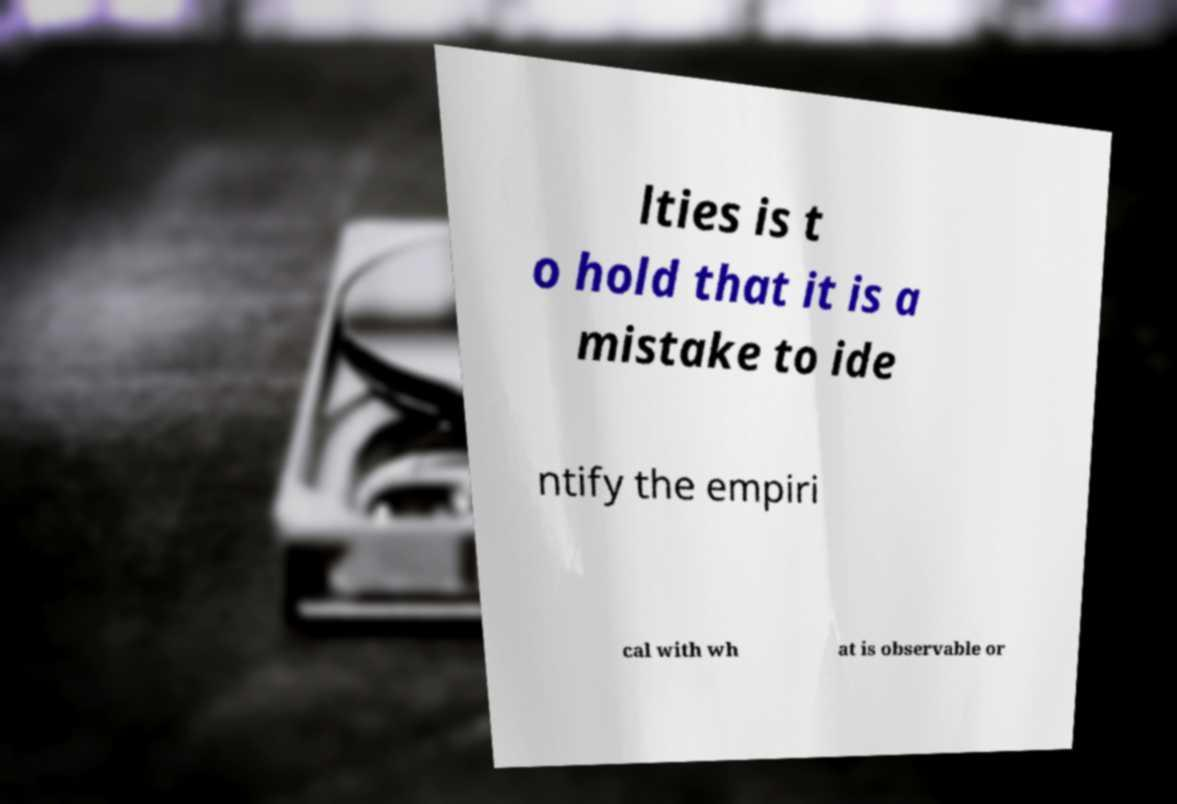Could you extract and type out the text from this image? lties is t o hold that it is a mistake to ide ntify the empiri cal with wh at is observable or 